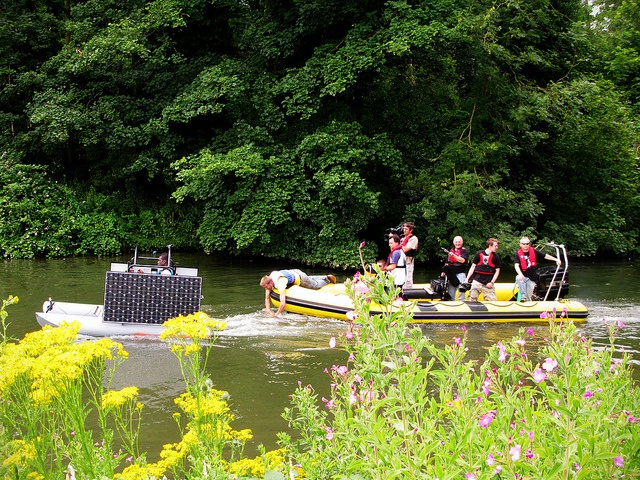Describe the objects in this image and their specific colors. I can see boat in black, white, gray, and darkgray tones, boat in black, ivory, gold, and khaki tones, people in black, lightgray, salmon, and darkgray tones, people in black, lightgray, lightpink, and tan tones, and people in black, white, brown, lightpink, and darkgray tones in this image. 